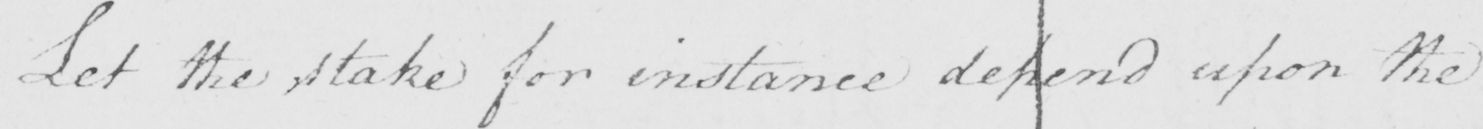What text is written in this handwritten line? Let the stake for instance depend upon the 